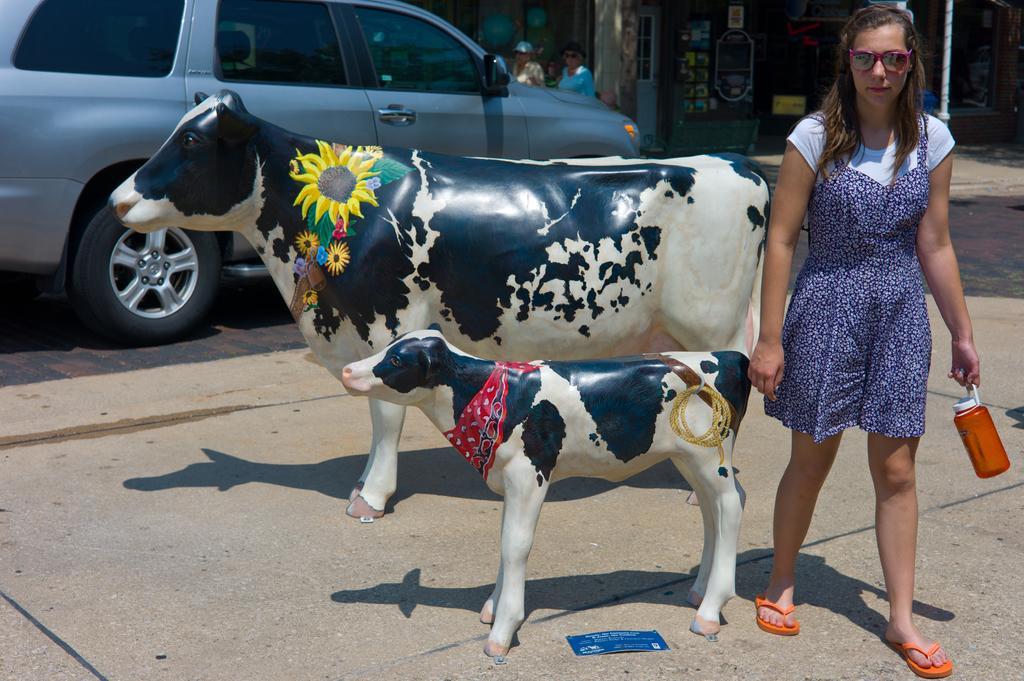Please provide a concise description of this image. In this image on the right side there is one woman who is walking and she is holding a bottle. In the foreground there are two toy cows, in the background there is a car and some persons are walking and also there are some buildings and some poles. At the bottom there is a walkway. 